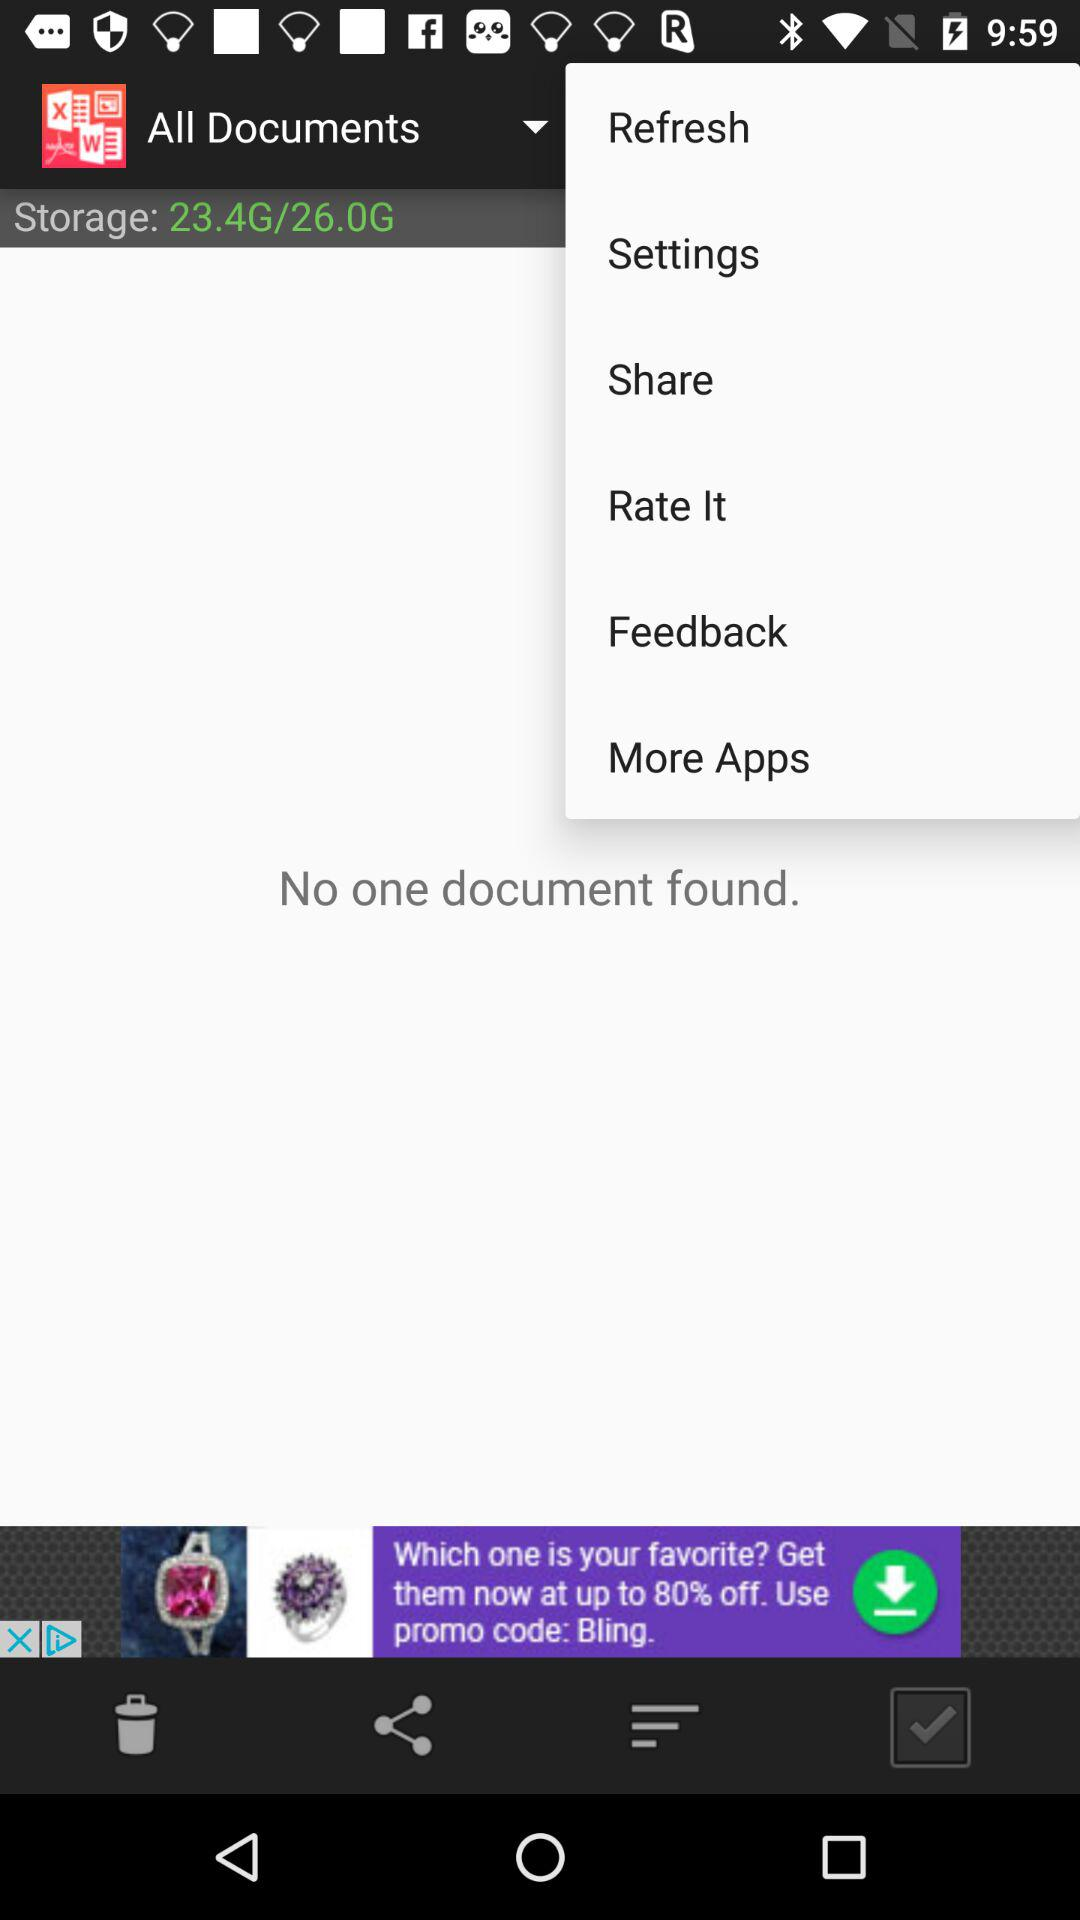How much is the total storage capacity? The total storage capacity is 26.0G. 